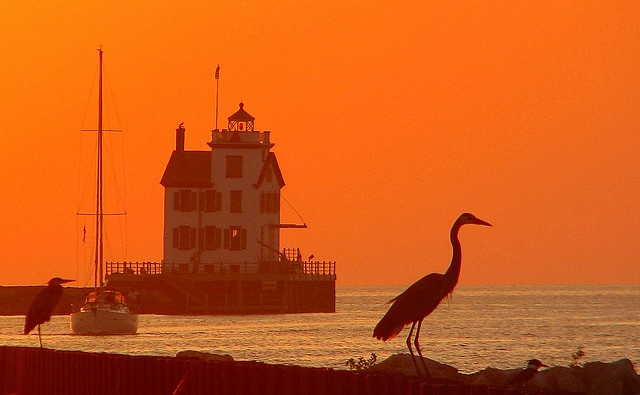Describe the objects in this image and their specific colors. I can see bird in orange, maroon, brown, and tan tones, boat in orange, maroon, brown, and red tones, bird in orange, maroon, and red tones, and bird in orange, maroon, olive, and red tones in this image. 